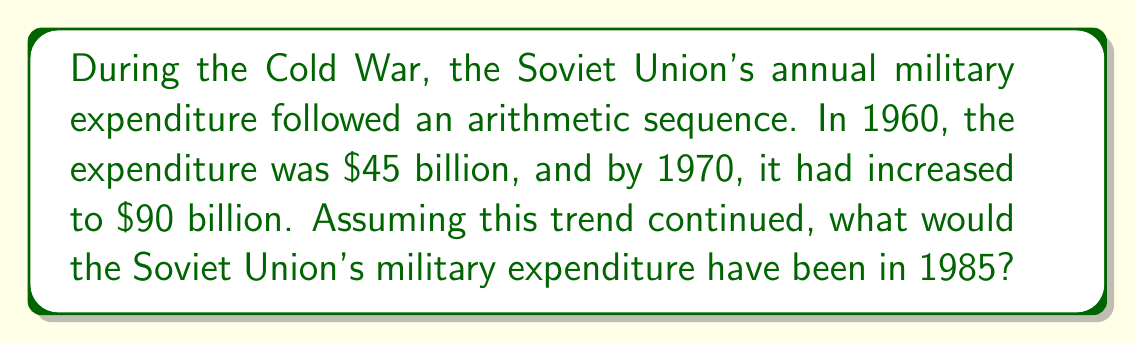Could you help me with this problem? Let's approach this step-by-step:

1) First, we need to identify the arithmetic sequence:
   $a_1 = 45$ billion (1960)
   $a_{11} = 90$ billion (1970)

2) We can find the common difference (d) using the formula:
   $a_n = a_1 + (n-1)d$
   $90 = 45 + (11-1)d$
   $90 = 45 + 10d$
   $45 = 10d$
   $d = 4.5$ billion per year

3) Now we know the sequence is $a_n = 45 + (n-1)4.5$

4) We need to find the value for 1985, which is 26 years after 1960:
   $a_{26} = 45 + (26-1)4.5$
   $a_{26} = 45 + (25)4.5$
   $a_{26} = 45 + 112.5$
   $a_{26} = 157.5$ billion

Therefore, if the trend continued, the Soviet Union's military expenditure in 1985 would have been $157.5 billion.
Answer: $157.5 billion 